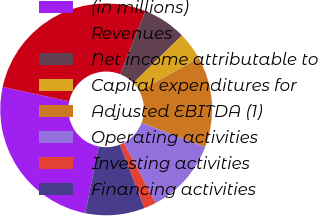<chart> <loc_0><loc_0><loc_500><loc_500><pie_chart><fcel>(in millions)<fcel>Revenues<fcel>Net income attributable to<fcel>Capital expenditures for<fcel>Adjusted EBITDA (1)<fcel>Operating activities<fcel>Investing activities<fcel>Financing activities<nl><fcel>25.24%<fcel>27.63%<fcel>6.66%<fcel>4.26%<fcel>13.84%<fcel>11.45%<fcel>1.87%<fcel>9.05%<nl></chart> 